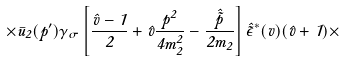Convert formula to latex. <formula><loc_0><loc_0><loc_500><loc_500>\times \bar { u } _ { 2 } ( p ^ { \prime } ) \gamma _ { \sigma } \left [ \frac { \hat { v } - 1 } { 2 } + \hat { v } \frac { { p } ^ { 2 } } { 4 m _ { 2 } ^ { 2 } } - \frac { \hat { \tilde { p } } } { 2 m _ { 2 } } \right ] \hat { \tilde { \epsilon } } ^ { \ast } ( v ) ( \hat { v } + 1 ) \times</formula> 